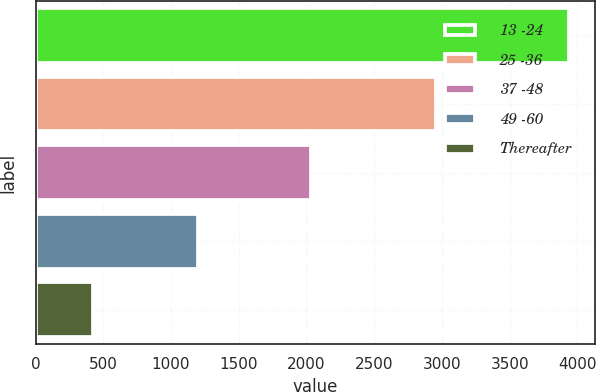<chart> <loc_0><loc_0><loc_500><loc_500><bar_chart><fcel>13 -24<fcel>25 -36<fcel>37 -48<fcel>49 -60<fcel>Thereafter<nl><fcel>3937<fcel>2960<fcel>2032<fcel>1196<fcel>423<nl></chart> 